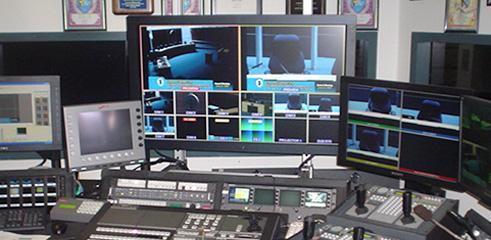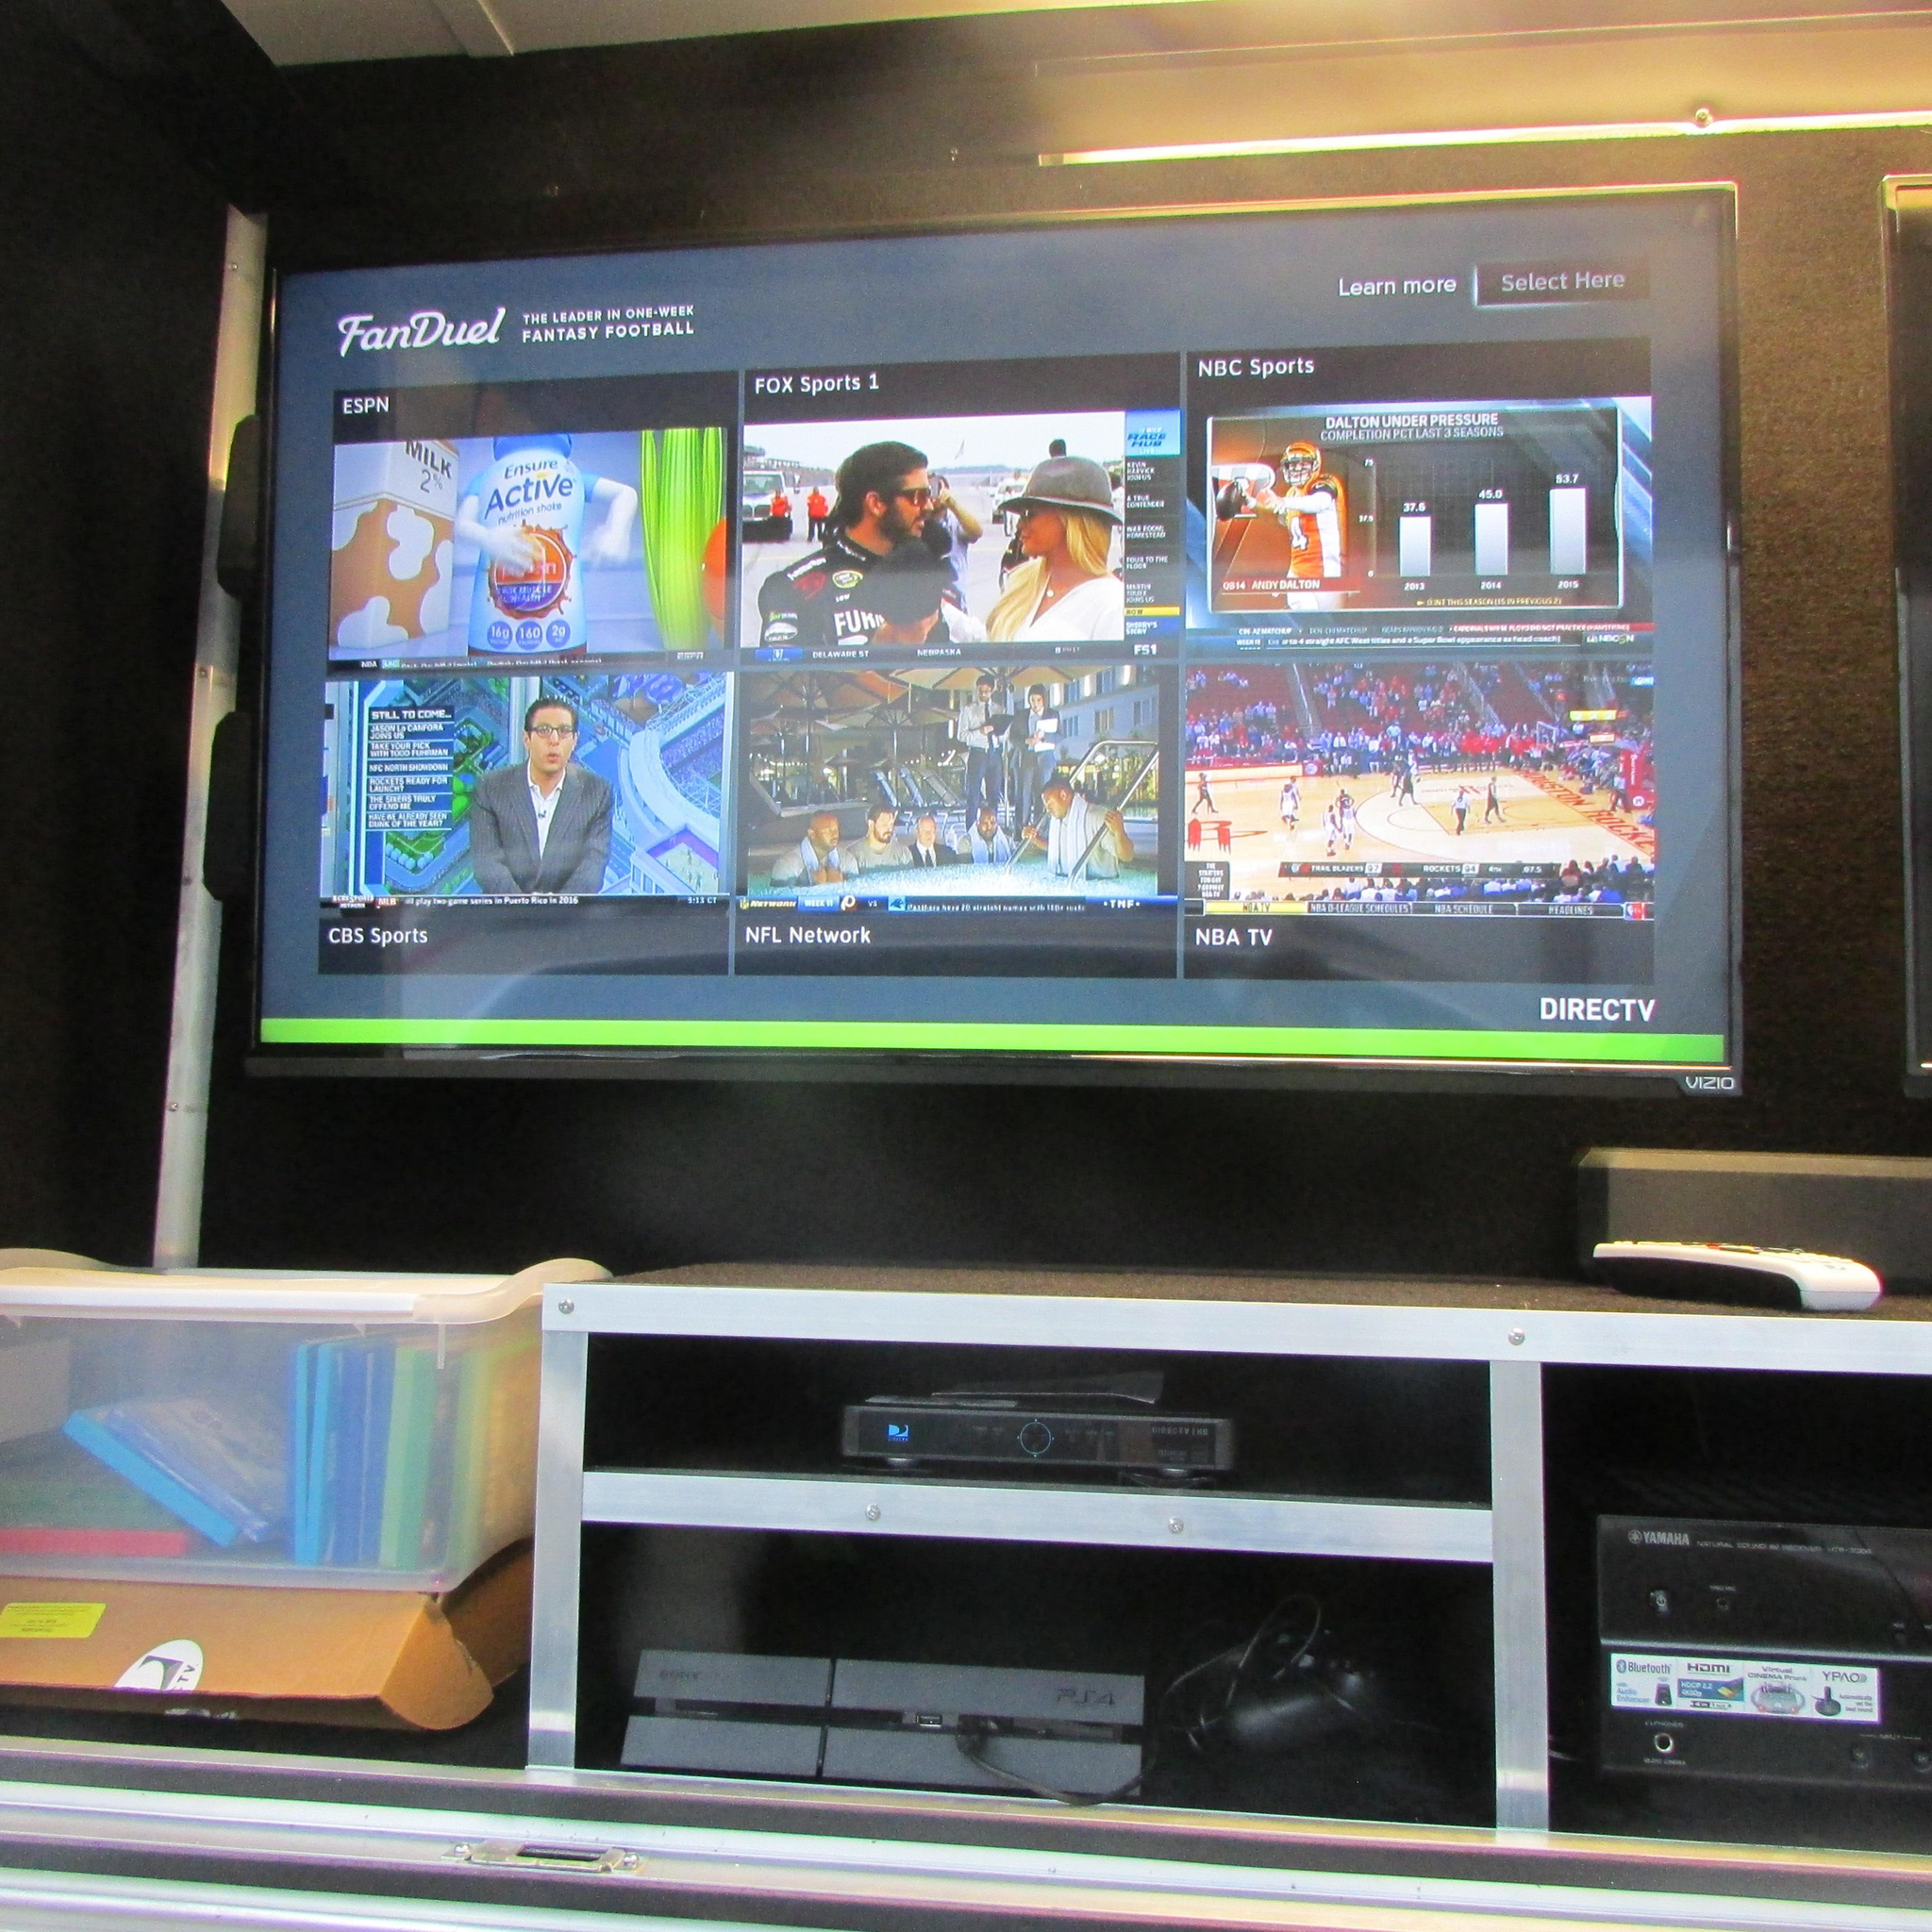The first image is the image on the left, the second image is the image on the right. Examine the images to the left and right. Is the description "In at least one of the images, humans are present, probably discussing how best to deliver the news." accurate? Answer yes or no. No. The first image is the image on the left, the second image is the image on the right. Evaluate the accuracy of this statement regarding the images: "At least one image includes people facing large screens in front of them.". Is it true? Answer yes or no. No. 